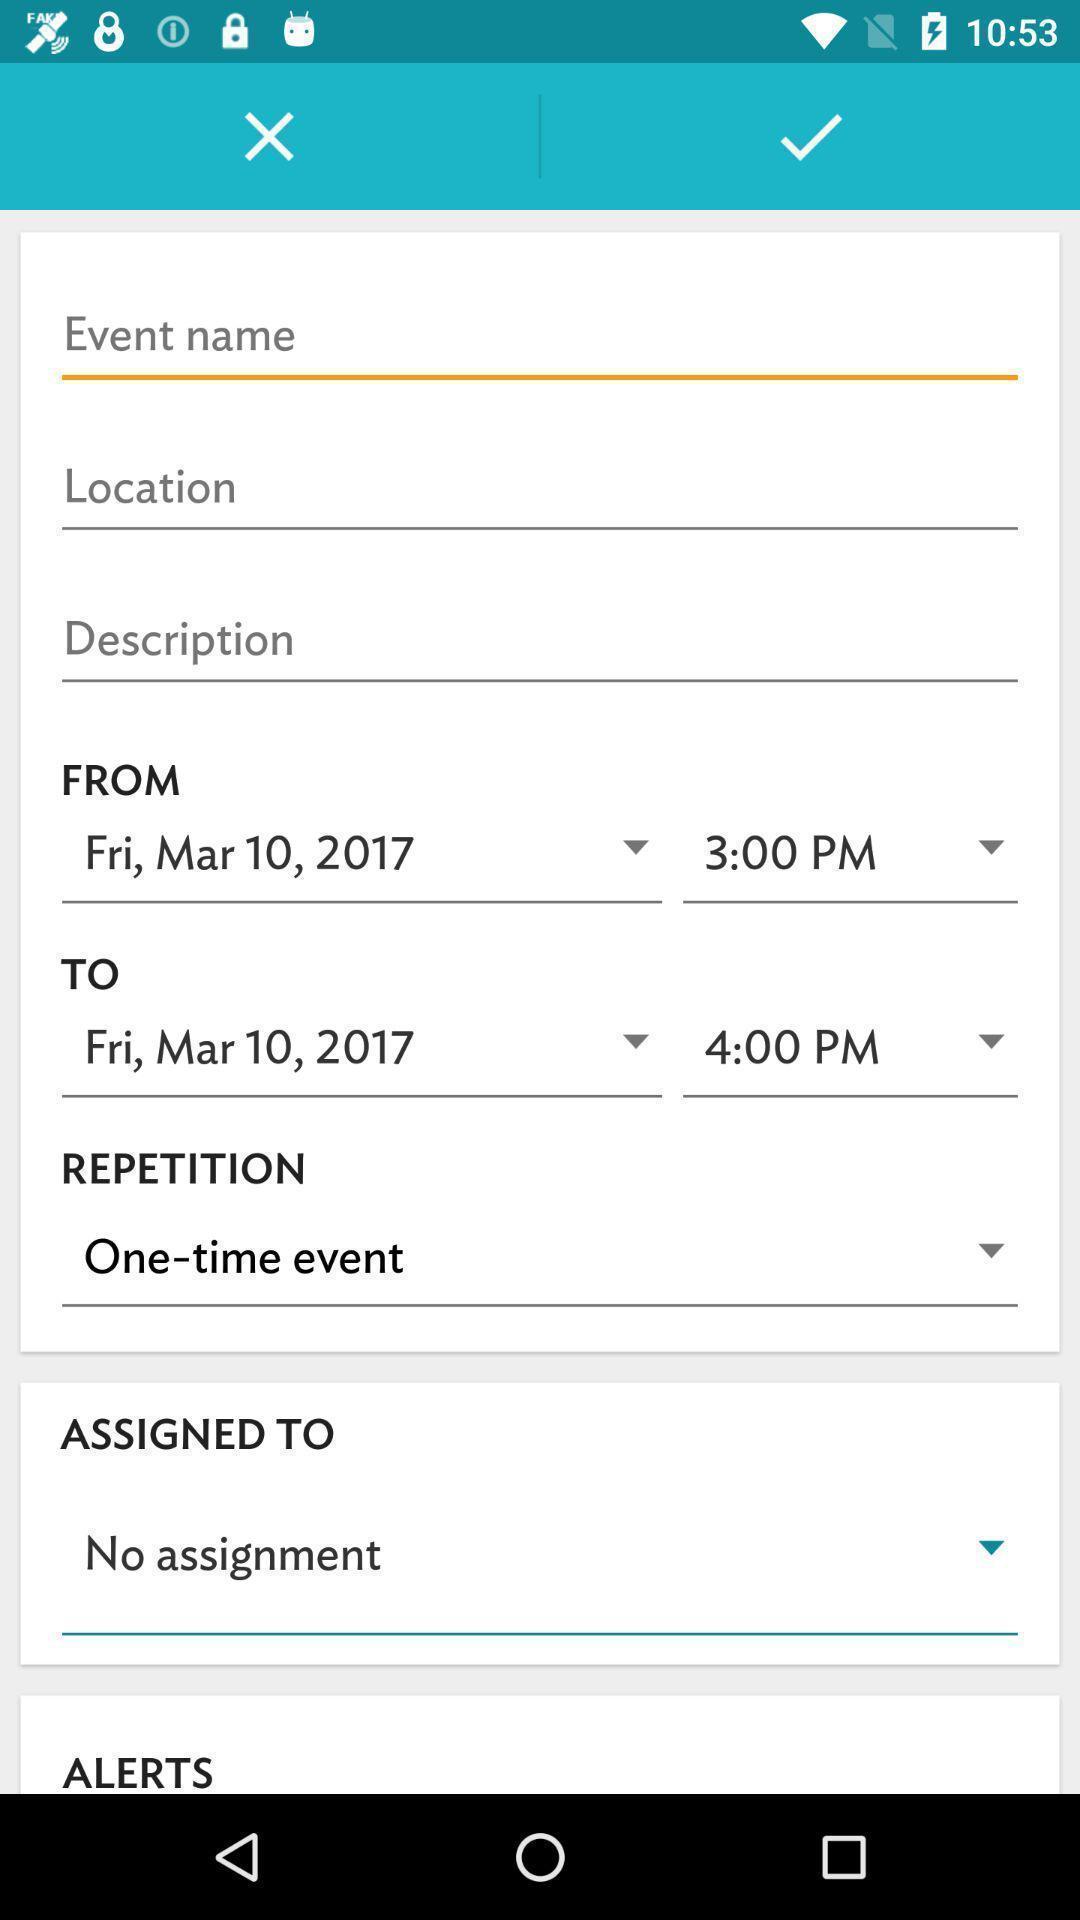Explain what's happening in this screen capture. Text boxes to enter your credentials in the application. 